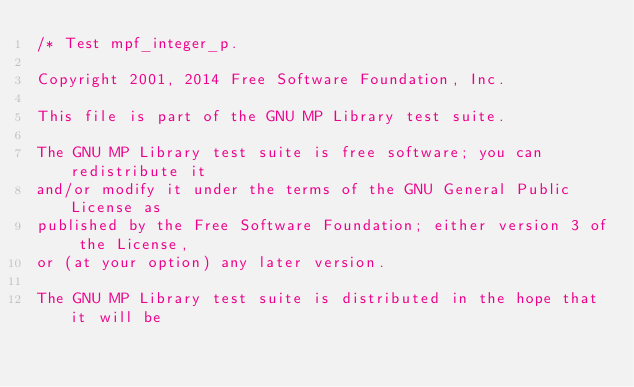Convert code to text. <code><loc_0><loc_0><loc_500><loc_500><_C_>/* Test mpf_integer_p.

Copyright 2001, 2014 Free Software Foundation, Inc.

This file is part of the GNU MP Library test suite.

The GNU MP Library test suite is free software; you can redistribute it
and/or modify it under the terms of the GNU General Public License as
published by the Free Software Foundation; either version 3 of the License,
or (at your option) any later version.

The GNU MP Library test suite is distributed in the hope that it will be</code> 